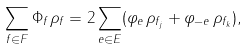Convert formula to latex. <formula><loc_0><loc_0><loc_500><loc_500>\sum _ { f \in F } \Phi _ { f } \rho _ { f } = 2 \sum _ { e \in E } ( \varphi _ { e } \, \rho _ { f _ { j } } + \varphi _ { - e } \, \rho _ { f _ { k } } ) ,</formula> 